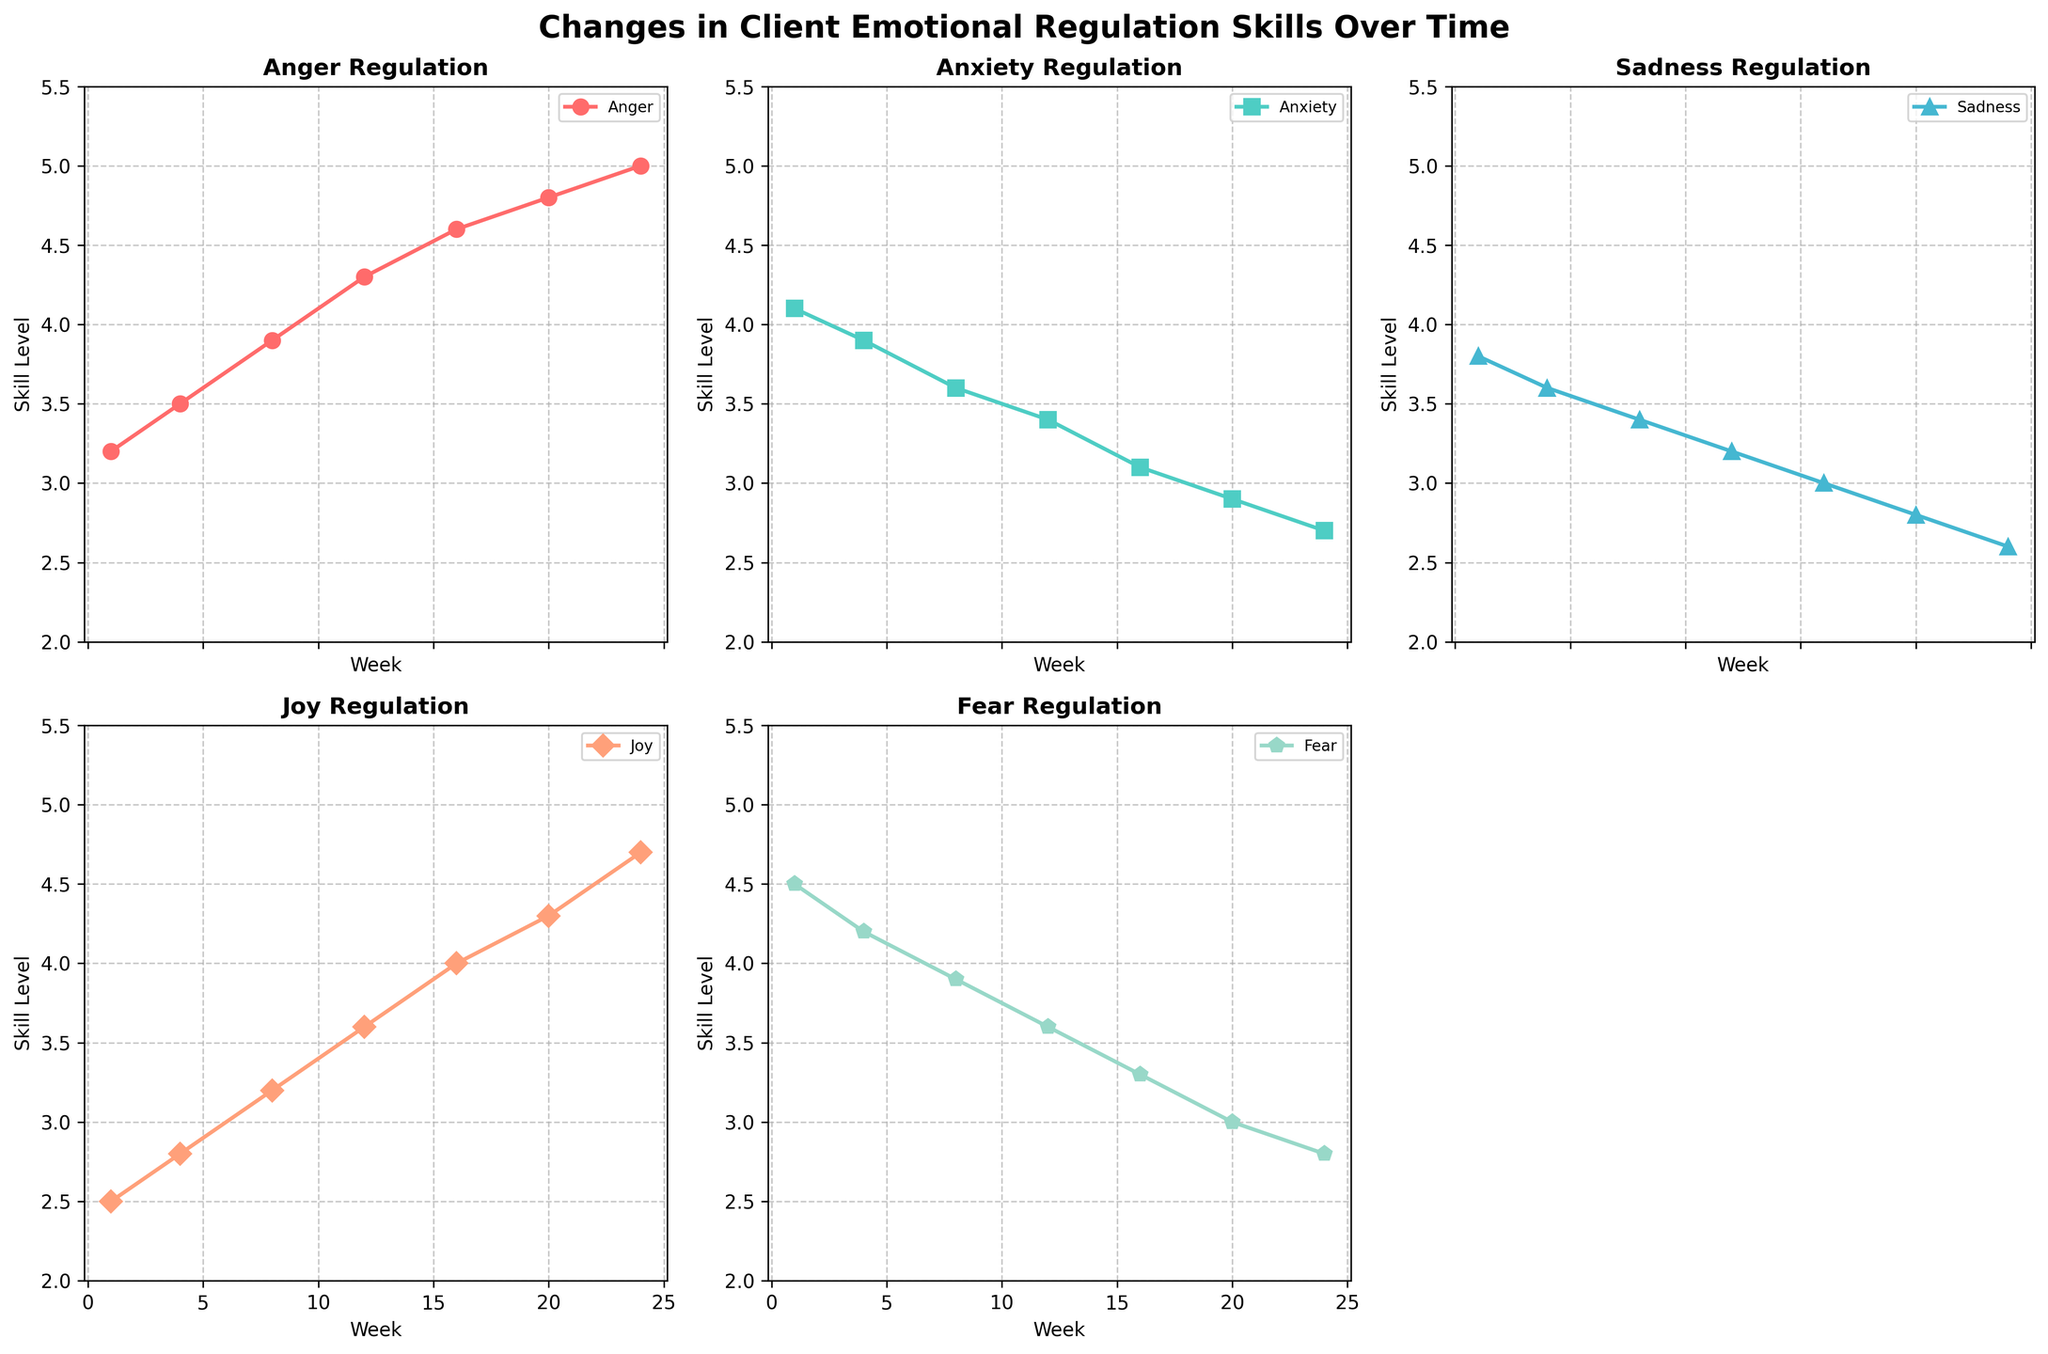What is the title of the figure? The title is displayed at the top of the figure; it is "Changes in Client Emotional Regulation Skills Over Time".
Answer: Changes in Client Emotional Regulation Skills Over Time Which emotion has the highest skill level at Week 24? From the line representing Week 24 and observing each subplot, the highest skill level is found in the "Joy" subplot.
Answer: Joy How many subplots are present in the figure? Count all the individual plots within the figure. Notice there are five labeled subplots and one empty space, making a total of 6 divided areas but 5 with data.
Answer: 5 By how much did the skill level for Anger increase from Week 1 to Week 24? Look at the Anger subplot, find the values at Week 1 (3.2) and Week 24 (5.0). Subtract the starting value from the ending value: 5.0 - 3.2 = 1.8.
Answer: 1.8 Which emotion shows a decreasing trend over the observed weeks? Observe the slopes of the lines in each subplot. "Anxiety" shows a consistently decreasing trend.
Answer: Anxiety Between Weeks 8 and 20, which emotion has the most significant increase in skill levels? Calculate the differences for each emotion between Weeks 8 and 20. Anger: 4.8 - 3.9 = 0.9, Anxiety: 3.6 - 2.9 = 0.7, Sadness: 3.4 - 2.8 = 0.6, Joy: 4.3 - 3.2 = 1.1, Fear: 3.0 - 3.9 = -0.9. "Joy" has the most significant increase.
Answer: Joy Which subplot has markers that are octagon-shaped? Identify the marker shapes used within each subplot by visual inspection. The subplot for "Fear" (marker 'p') has octagon-shaped markers.
Answer: Fear In which week does the skill level for "Fear" drop below the skill level for "Sadness"? Compare weekly values in both the "Fear" and "Sadness" subplots to find where the crossover occurs. At Week 20, the skill level for Fear (3.0) is below Sadness (2.8).
Answer: Week 20 What is the average skill level for "Joy" across all weeks shown? Sum the skill levels across all weeks for Joy (2.5 + 2.8 + 3.2 + 3.6 + 4.0 + 4.3 + 4.7) and divide by the number of weeks (7). Total is 25.1, average is 25.1/7 ≈ 3.6.
Answer: 3.6 Which emotion had the least variation in skill levels over time? Calculate the range (max-min) for each emotion. Anger: 5.0 - 3.2 = 1.8, Anxiety: 4.1 - 2.7 = 1.4, Sadness: 3.8 - 2.6 = 1.2, Joy: 4.7 - 2.5 = 2.2, Fear: 4.5 - 2.8 = 1.7. "Sadness" has the least variation (1.2).
Answer: Sadness 